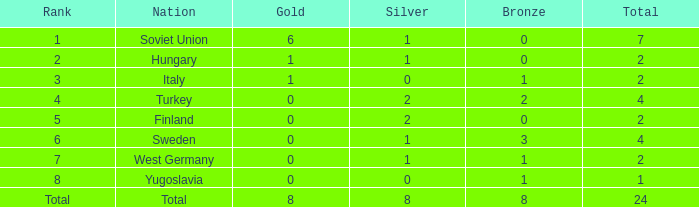What is the average Bronze, when Total is 7, and when Silver is greater than 1? None. 